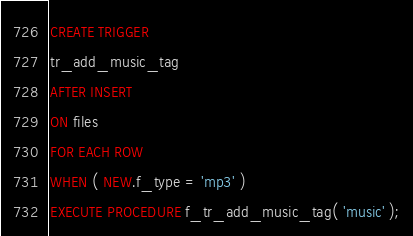Convert code to text. <code><loc_0><loc_0><loc_500><loc_500><_SQL_>CREATE TRIGGER
tr_add_music_tag
AFTER INSERT 
ON files
FOR EACH ROW
WHEN ( NEW.f_type = 'mp3' )
EXECUTE PROCEDURE f_tr_add_music_tag( 'music' );
</code> 